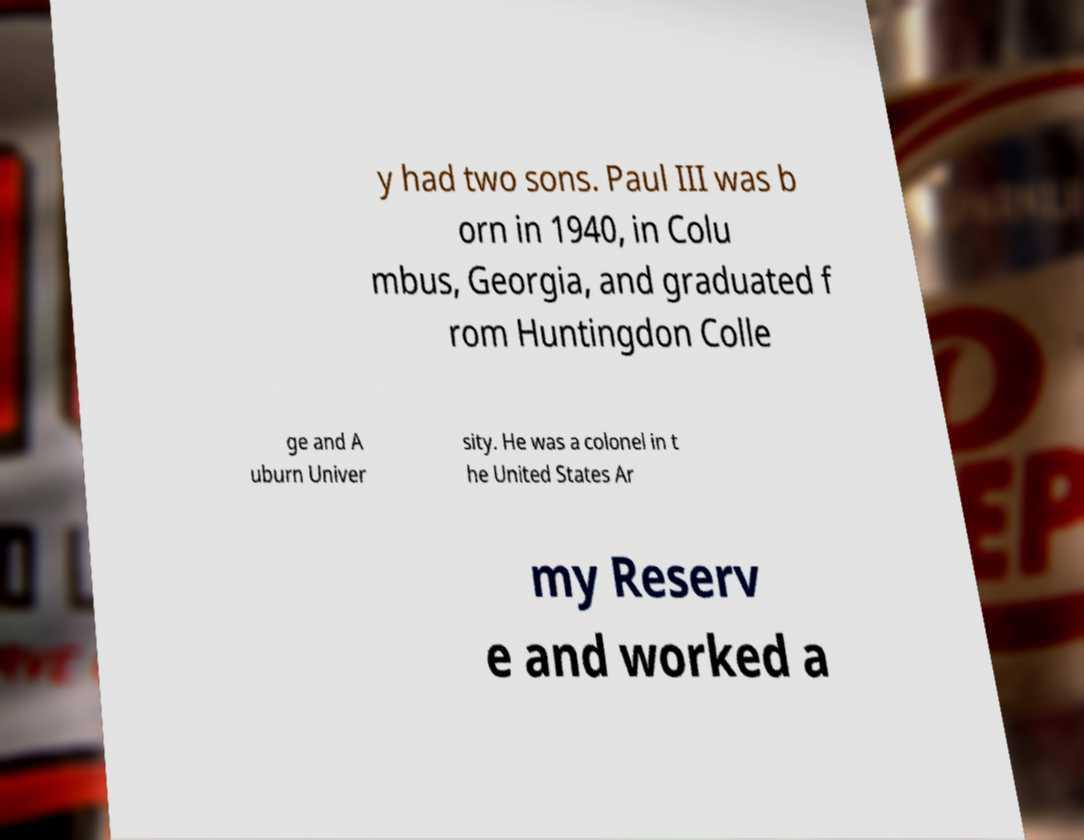Can you read and provide the text displayed in the image?This photo seems to have some interesting text. Can you extract and type it out for me? y had two sons. Paul III was b orn in 1940, in Colu mbus, Georgia, and graduated f rom Huntingdon Colle ge and A uburn Univer sity. He was a colonel in t he United States Ar my Reserv e and worked a 